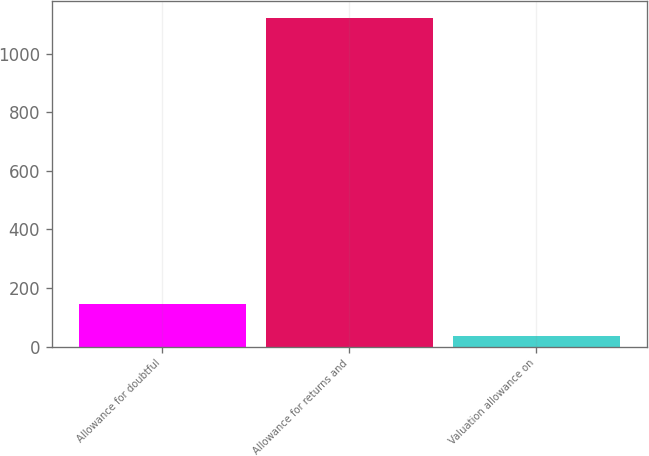<chart> <loc_0><loc_0><loc_500><loc_500><bar_chart><fcel>Allowance for doubtful<fcel>Allowance for returns and<fcel>Valuation allowance on<nl><fcel>145.5<fcel>1122<fcel>37<nl></chart> 